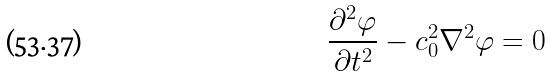Convert formula to latex. <formula><loc_0><loc_0><loc_500><loc_500>\frac { \partial ^ { 2 } \varphi } { \partial t ^ { 2 } } - c _ { 0 } ^ { 2 } \nabla ^ { 2 } \varphi = 0</formula> 